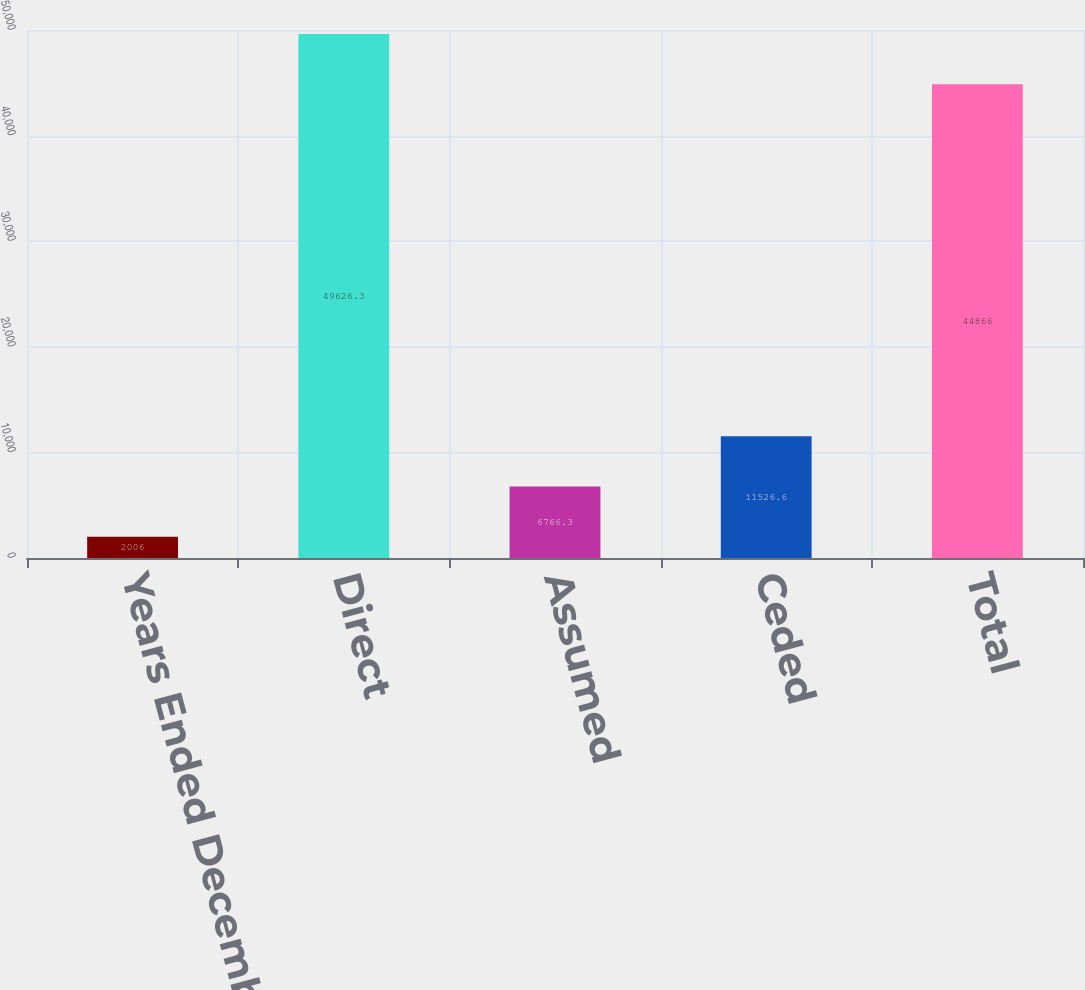<chart> <loc_0><loc_0><loc_500><loc_500><bar_chart><fcel>Years Ended December 31 (in<fcel>Direct<fcel>Assumed<fcel>Ceded<fcel>Total<nl><fcel>2006<fcel>49626.3<fcel>6766.3<fcel>11526.6<fcel>44866<nl></chart> 